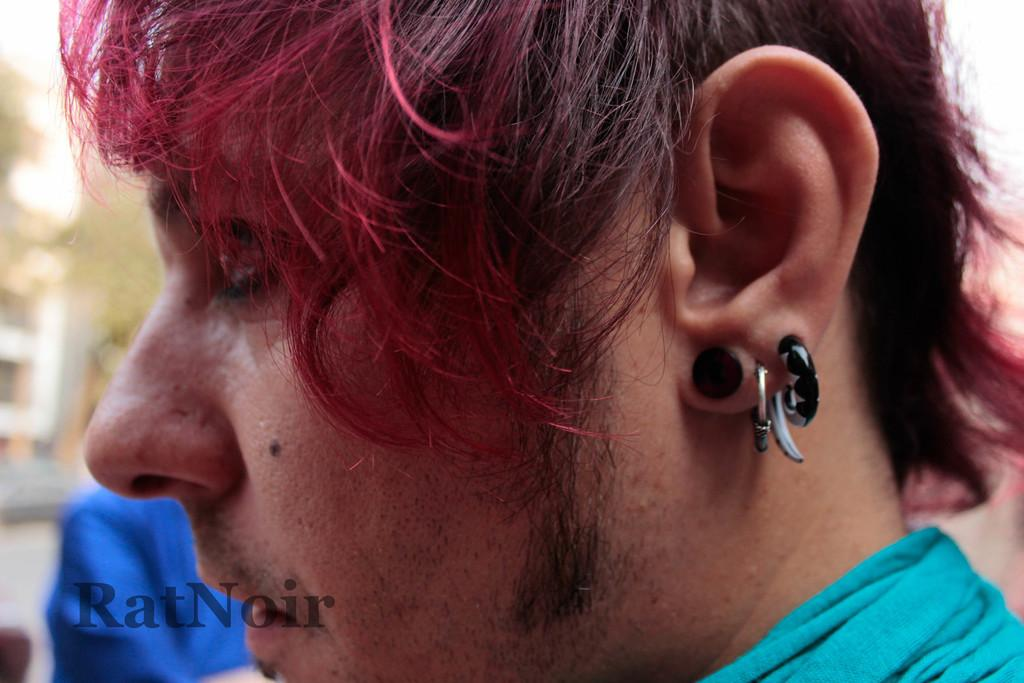What is present in the image? There is a person in the image. Can you describe the person's appearance? The person is wearing clothes. Are there any accessories visible in the image? Yes, there is an ear stud and an earring in the image. Is there any text or marking on the image? Yes, there is a watermark in the image. How would you describe the background of the image? The background of the image is blurred. What type of bear can be seen controlling the traffic in the image? There is no bear present in the image, nor is there any indication of traffic control. 